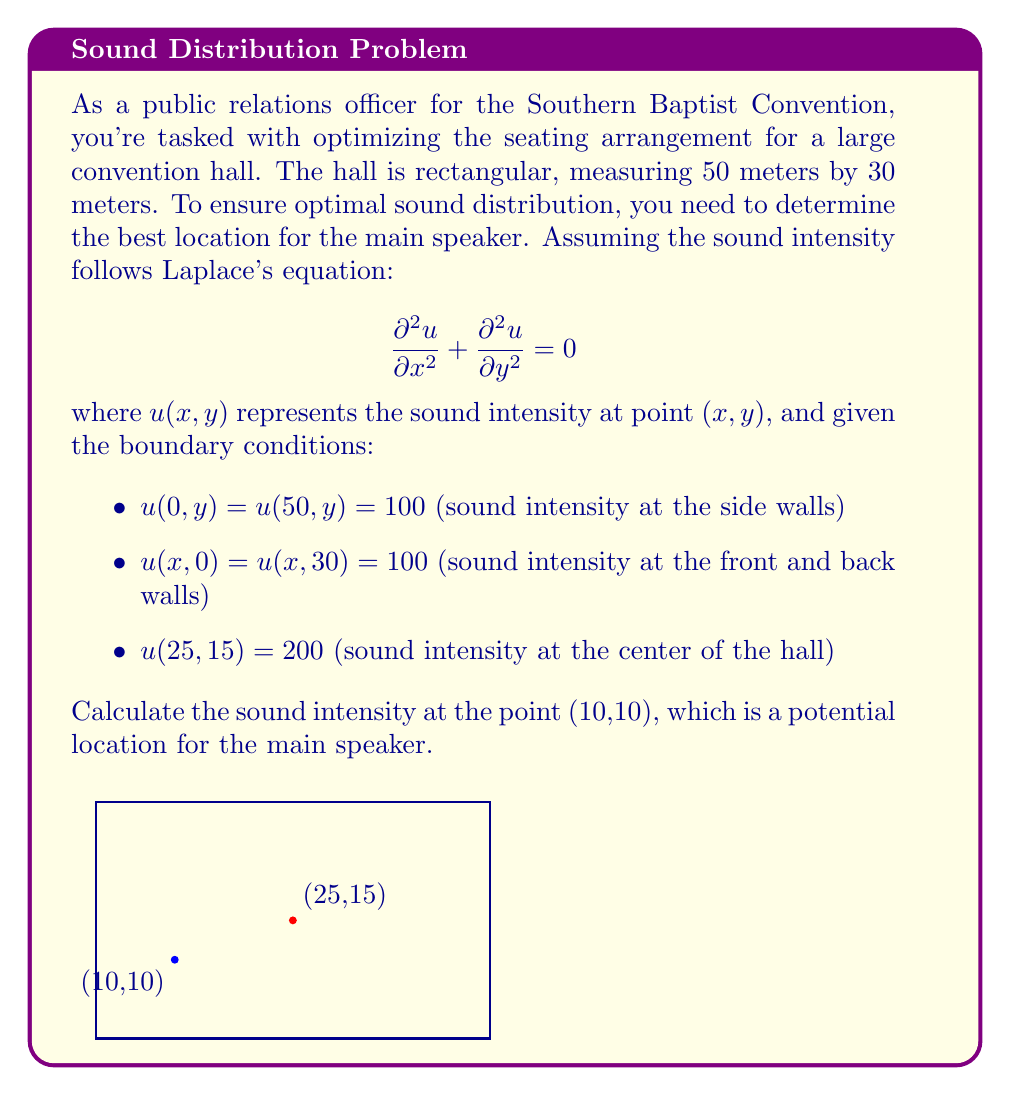Teach me how to tackle this problem. To solve this problem, we'll use the method of separation of variables for Laplace's equation.

1) Assume the solution has the form: $u(x,y) = X(x)Y(y)$

2) Substituting into Laplace's equation:
   $$X''(x)Y(y) + X(x)Y''(y) = 0$$
   $$\frac{X''(x)}{X(x)} = -\frac{Y''(y)}{Y(y)} = -\lambda^2$$

3) This leads to two ODEs:
   $$X''(x) + \lambda^2 X(x) = 0$$
   $$Y''(y) + \lambda^2 Y(y) = 0$$

4) The general solution is:
   $$u(x,y) = \sum_{n=1}^{\infty} (A_n \sinh(\lambda_n x) + B_n \cosh(\lambda_n x))(C_n \sinh(\lambda_n y) + D_n \cosh(\lambda_n y))$$

5) Applying the boundary conditions:
   $$u(0,y) = u(50,y) = 100 \implies B_n = 100, A_n \sinh(50\lambda_n) + 100\cosh(50\lambda_n) = 100$$
   $$u(x,0) = u(x,30) = 100 \implies D_n = 100, C_n \sinh(30\lambda_n) + 100\cosh(30\lambda_n) = 100$$

6) The solution satisfying these conditions is:
   $$u(x,y) = 100 + \sum_{n=1}^{\infty} a_n \sinh(\lambda_n x) \sinh(\lambda_n y)$$
   where $\lambda_n = \frac{n\pi}{50}$

7) To find $a_n$, we use the condition $u(25,15) = 200$:
   $$200 = 100 + \sum_{n=1}^{\infty} a_n \sinh(\frac{n\pi}{2}) \sinh(\frac{3n\pi}{10})$$

8) Approximating with the first term (n=1):
   $$a_1 \approx \frac{100}{\sinh(\frac{\pi}{2}) \sinh(\frac{3\pi}{10})} \approx 131.2$$

9) The approximate solution is:
   $$u(x,y) \approx 100 + 131.2 \sinh(\frac{\pi x}{50}) \sinh(\frac{\pi y}{30})$$

10) Evaluating at (10,10):
    $$u(10,10) \approx 100 + 131.2 \sinh(\frac{\pi}{5}) \sinh(\frac{\pi}{3}) \approx 153.6$$
Answer: 153.6 